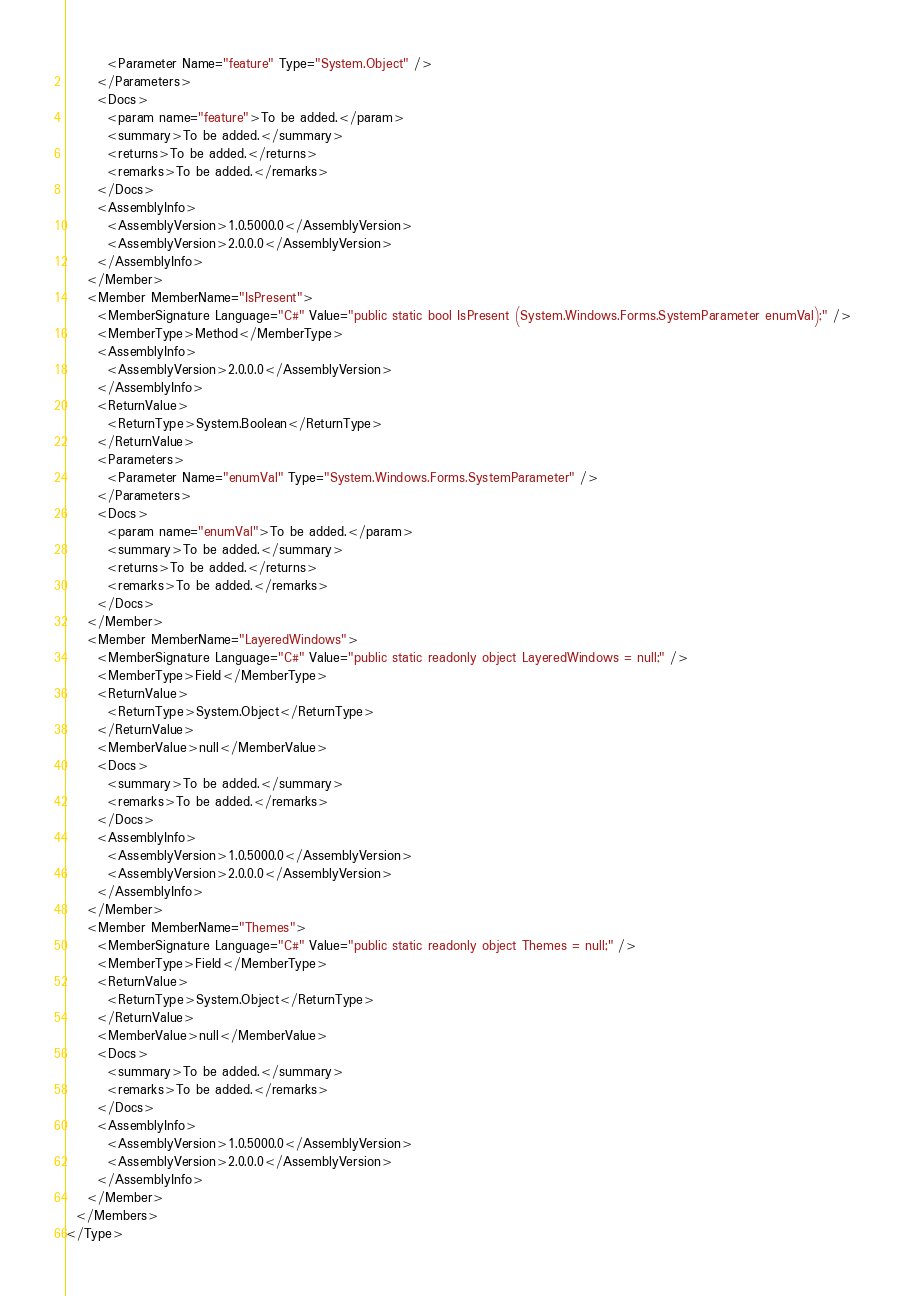<code> <loc_0><loc_0><loc_500><loc_500><_XML_>        <Parameter Name="feature" Type="System.Object" />
      </Parameters>
      <Docs>
        <param name="feature">To be added.</param>
        <summary>To be added.</summary>
        <returns>To be added.</returns>
        <remarks>To be added.</remarks>
      </Docs>
      <AssemblyInfo>
        <AssemblyVersion>1.0.5000.0</AssemblyVersion>
        <AssemblyVersion>2.0.0.0</AssemblyVersion>
      </AssemblyInfo>
    </Member>
    <Member MemberName="IsPresent">
      <MemberSignature Language="C#" Value="public static bool IsPresent (System.Windows.Forms.SystemParameter enumVal);" />
      <MemberType>Method</MemberType>
      <AssemblyInfo>
        <AssemblyVersion>2.0.0.0</AssemblyVersion>
      </AssemblyInfo>
      <ReturnValue>
        <ReturnType>System.Boolean</ReturnType>
      </ReturnValue>
      <Parameters>
        <Parameter Name="enumVal" Type="System.Windows.Forms.SystemParameter" />
      </Parameters>
      <Docs>
        <param name="enumVal">To be added.</param>
        <summary>To be added.</summary>
        <returns>To be added.</returns>
        <remarks>To be added.</remarks>
      </Docs>
    </Member>
    <Member MemberName="LayeredWindows">
      <MemberSignature Language="C#" Value="public static readonly object LayeredWindows = null;" />
      <MemberType>Field</MemberType>
      <ReturnValue>
        <ReturnType>System.Object</ReturnType>
      </ReturnValue>
      <MemberValue>null</MemberValue>
      <Docs>
        <summary>To be added.</summary>
        <remarks>To be added.</remarks>
      </Docs>
      <AssemblyInfo>
        <AssemblyVersion>1.0.5000.0</AssemblyVersion>
        <AssemblyVersion>2.0.0.0</AssemblyVersion>
      </AssemblyInfo>
    </Member>
    <Member MemberName="Themes">
      <MemberSignature Language="C#" Value="public static readonly object Themes = null;" />
      <MemberType>Field</MemberType>
      <ReturnValue>
        <ReturnType>System.Object</ReturnType>
      </ReturnValue>
      <MemberValue>null</MemberValue>
      <Docs>
        <summary>To be added.</summary>
        <remarks>To be added.</remarks>
      </Docs>
      <AssemblyInfo>
        <AssemblyVersion>1.0.5000.0</AssemblyVersion>
        <AssemblyVersion>2.0.0.0</AssemblyVersion>
      </AssemblyInfo>
    </Member>
  </Members>
</Type>
</code> 